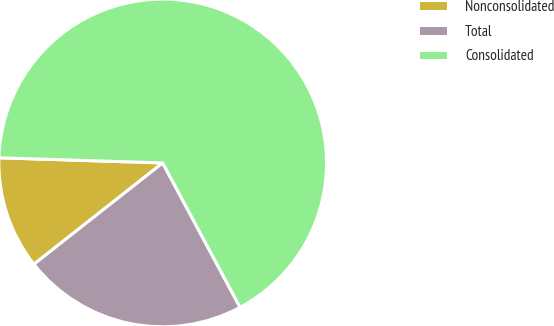Convert chart to OTSL. <chart><loc_0><loc_0><loc_500><loc_500><pie_chart><fcel>Nonconsolidated<fcel>Total<fcel>Consolidated<nl><fcel>11.11%<fcel>22.22%<fcel>66.67%<nl></chart> 